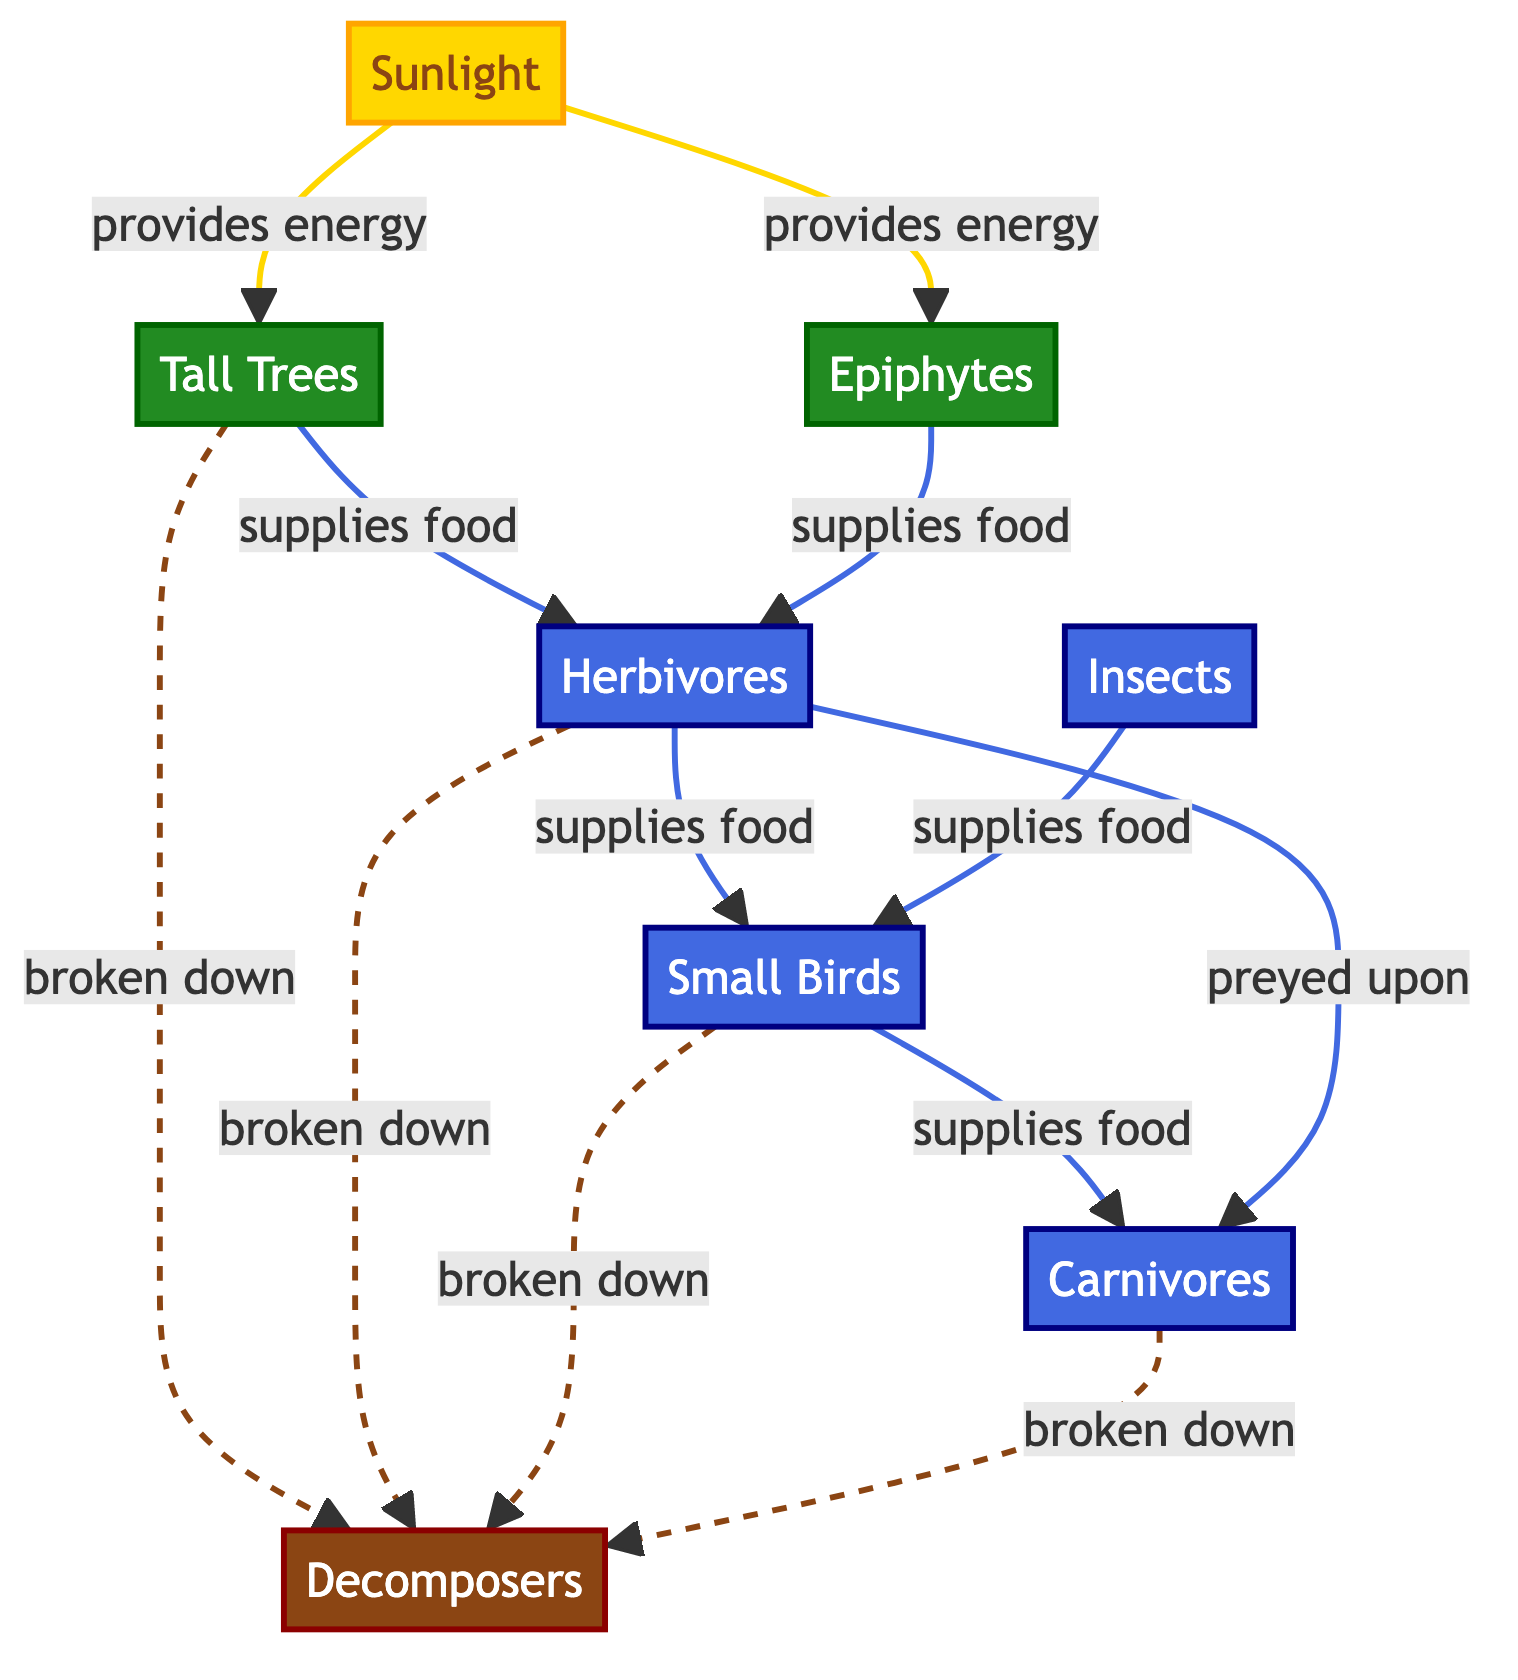What are the producers in the diagram? The diagram lists two producers: Tall Trees and Epiphytes, both connected to the Sunlight node, indicating that they derive energy from sunlight and contribute to the food web.
Answer: Tall Trees and Epiphytes How many consumer nodes are there in total? The diagram shows four consumer nodes: Herbivores, Small Birds, Insects, and Carnivores. By counting these nodes, we find the total number of consumers in the food chain.
Answer: Four Which consumer is preyed upon by carnivores? The diagram indicates that Herbivores are directly connected to Carnivores, meaning that they serve as the primary prey for the Carnivores in this food web.
Answer: Herbivores How does sunlight contribute to the food web? Sunlight is the initial energy source in the diagram, providing energy to both Tall Trees and Epiphytes, and from them, energy is supplied to Herbivores, showcasing its foundational role in the ecosystem.
Answer: Provides energy What role do decomposers play in this food web? The diagram shows that all types of producers and consumers are connected to Decomposers, indicating that they break down dead material, which recycles nutrients back into the ecosystem.
Answer: Nutrient recycling 